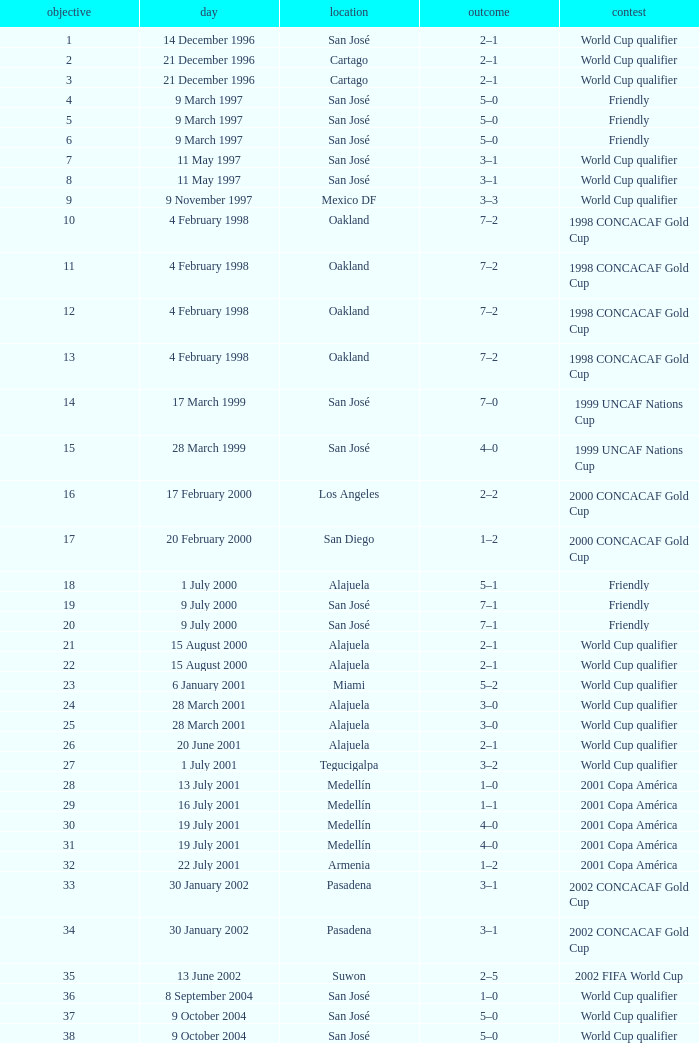What is the result in oakland? 7–2, 7–2, 7–2, 7–2. 